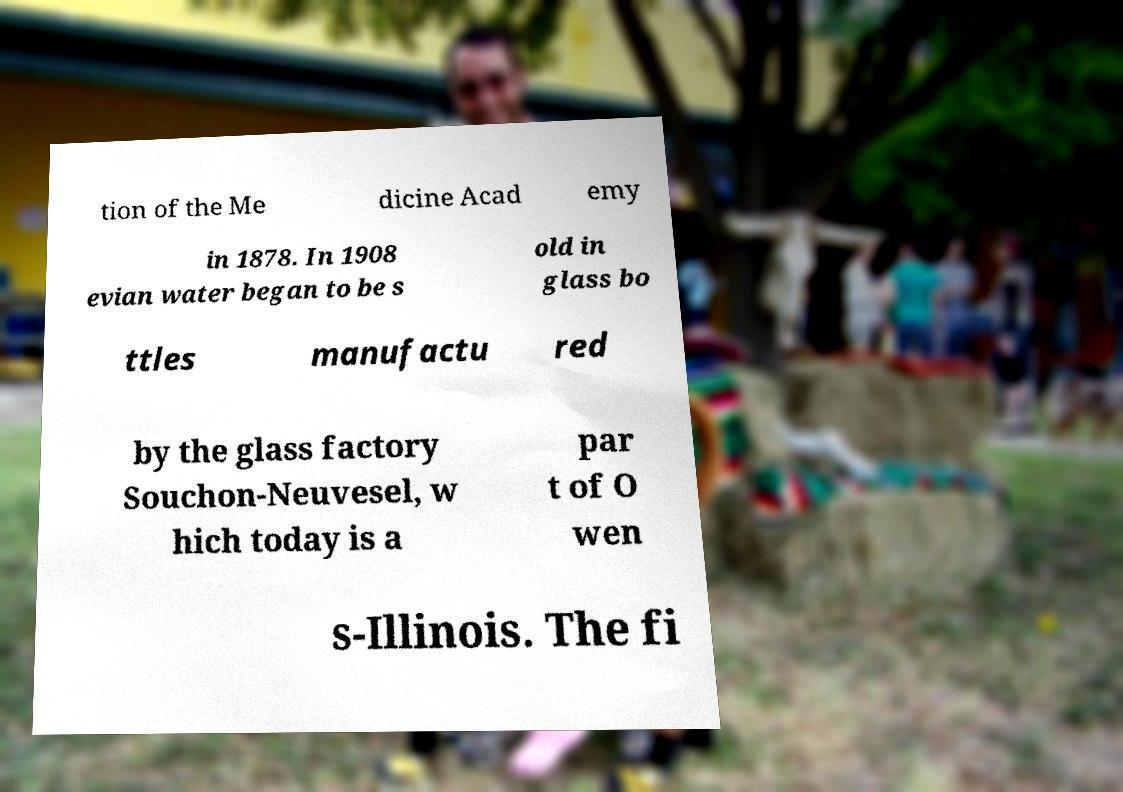Could you assist in decoding the text presented in this image and type it out clearly? tion of the Me dicine Acad emy in 1878. In 1908 evian water began to be s old in glass bo ttles manufactu red by the glass factory Souchon-Neuvesel, w hich today is a par t of O wen s-Illinois. The fi 